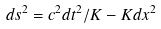<formula> <loc_0><loc_0><loc_500><loc_500>d s ^ { 2 } = c ^ { 2 } d t ^ { 2 } / K - K d x ^ { 2 }</formula> 